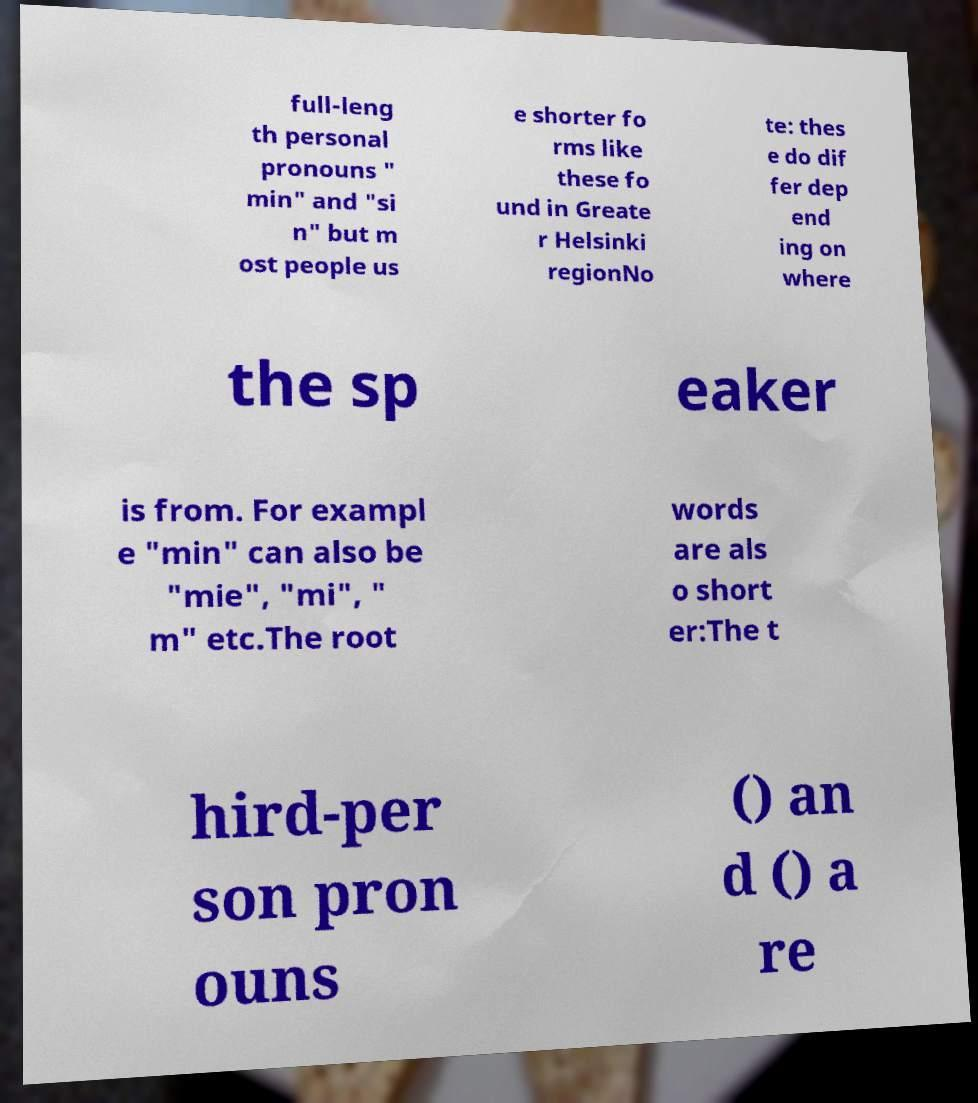I need the written content from this picture converted into text. Can you do that? full-leng th personal pronouns " min" and "si n" but m ost people us e shorter fo rms like these fo und in Greate r Helsinki regionNo te: thes e do dif fer dep end ing on where the sp eaker is from. For exampl e "min" can also be "mie", "mi", " m" etc.The root words are als o short er:The t hird-per son pron ouns () an d () a re 